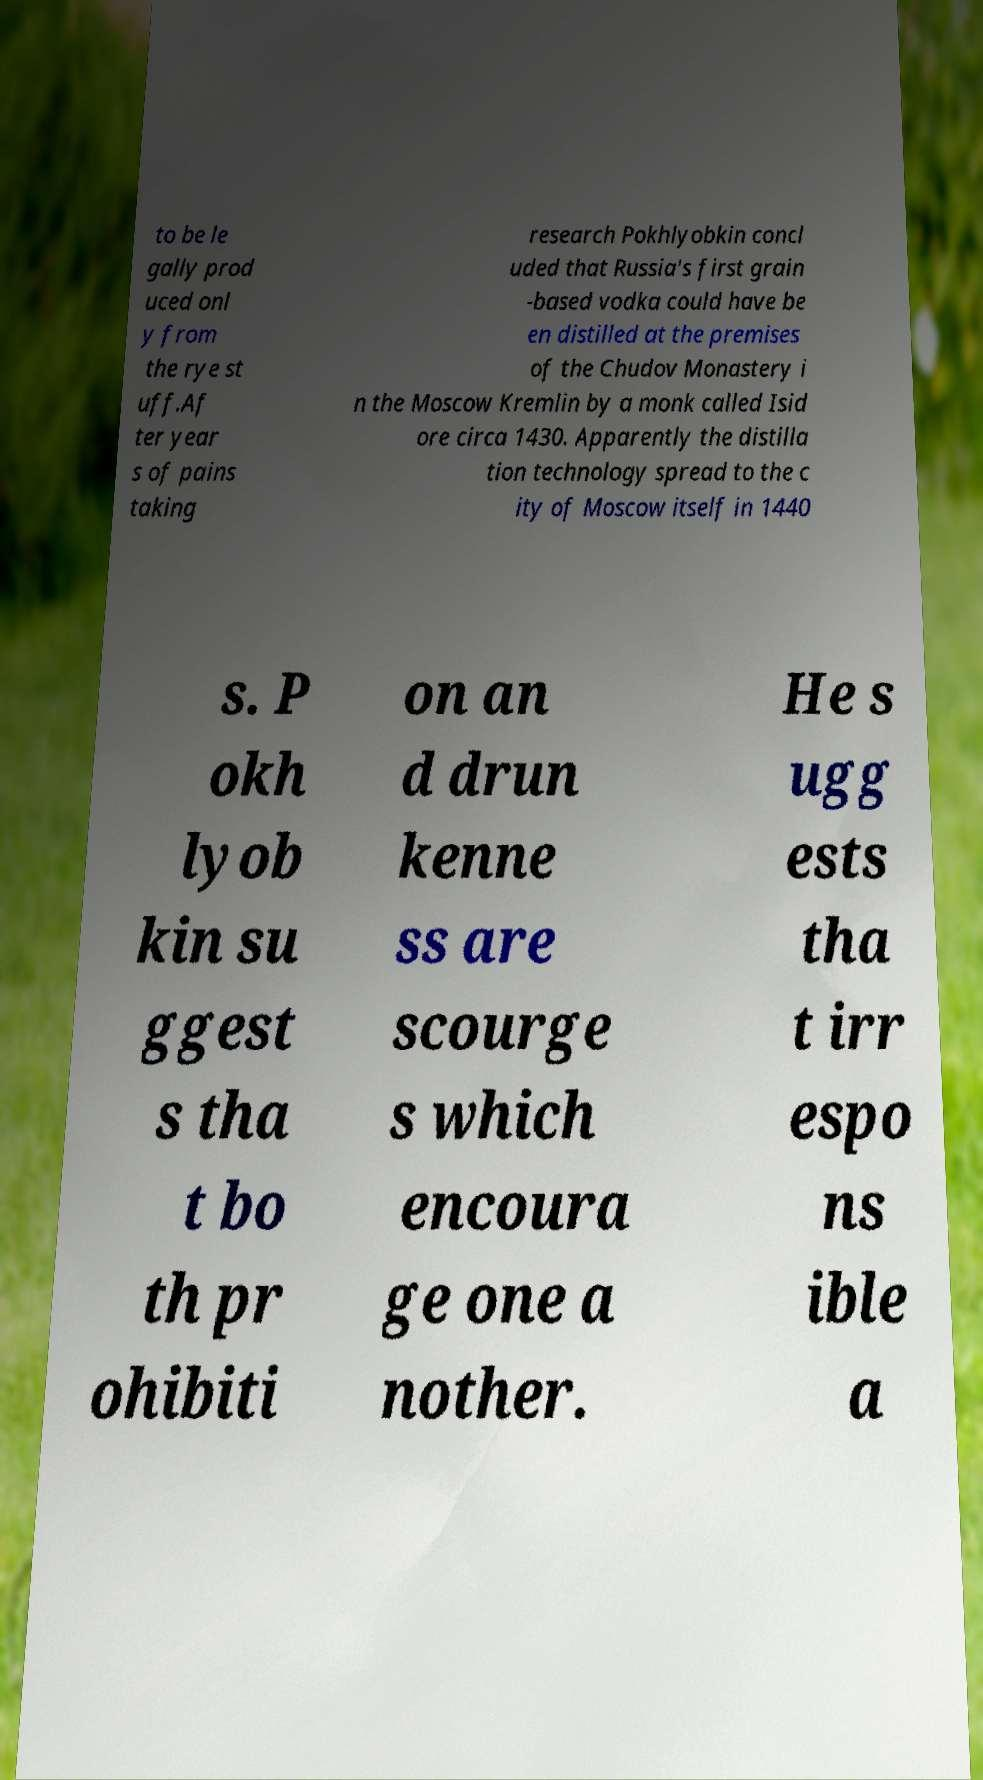Can you read and provide the text displayed in the image?This photo seems to have some interesting text. Can you extract and type it out for me? to be le gally prod uced onl y from the rye st uff.Af ter year s of pains taking research Pokhlyobkin concl uded that Russia's first grain -based vodka could have be en distilled at the premises of the Chudov Monastery i n the Moscow Kremlin by a monk called Isid ore circa 1430. Apparently the distilla tion technology spread to the c ity of Moscow itself in 1440 s. P okh lyob kin su ggest s tha t bo th pr ohibiti on an d drun kenne ss are scourge s which encoura ge one a nother. He s ugg ests tha t irr espo ns ible a 